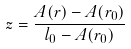<formula> <loc_0><loc_0><loc_500><loc_500>z = \frac { A ( r ) - A ( r _ { 0 } ) } { l _ { 0 } - A ( r _ { 0 } ) }</formula> 